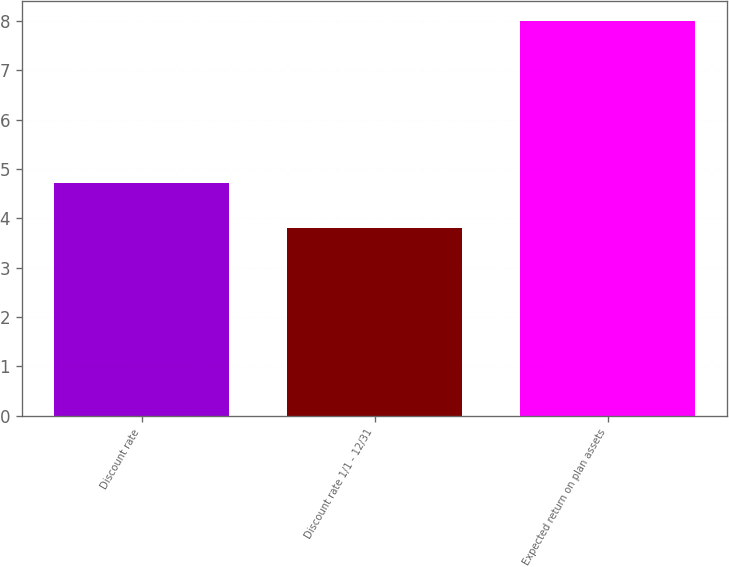Convert chart to OTSL. <chart><loc_0><loc_0><loc_500><loc_500><bar_chart><fcel>Discount rate<fcel>Discount rate 1/1 - 12/31<fcel>Expected return on plan assets<nl><fcel>4.71<fcel>3.8<fcel>8<nl></chart> 